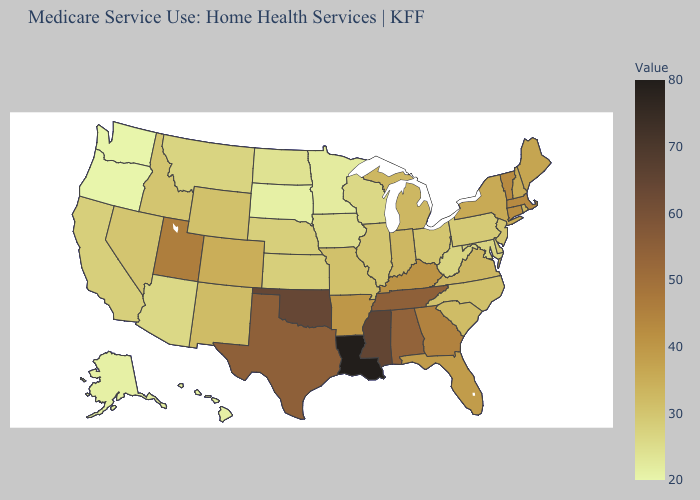Among the states that border Indiana , does Kentucky have the lowest value?
Concise answer only. No. Does South Carolina have a lower value than Georgia?
Keep it brief. Yes. Does New York have the highest value in the USA?
Short answer required. No. Does Pennsylvania have the lowest value in the Northeast?
Answer briefly. Yes. Which states hav the highest value in the MidWest?
Give a very brief answer. Indiana, Michigan. Which states hav the highest value in the Northeast?
Quick response, please. Massachusetts, Vermont. 